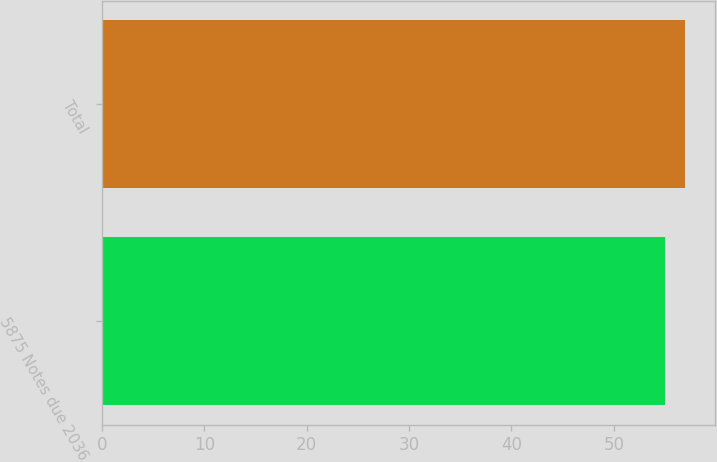<chart> <loc_0><loc_0><loc_500><loc_500><bar_chart><fcel>5875 Notes due 2036<fcel>Total<nl><fcel>55<fcel>57<nl></chart> 